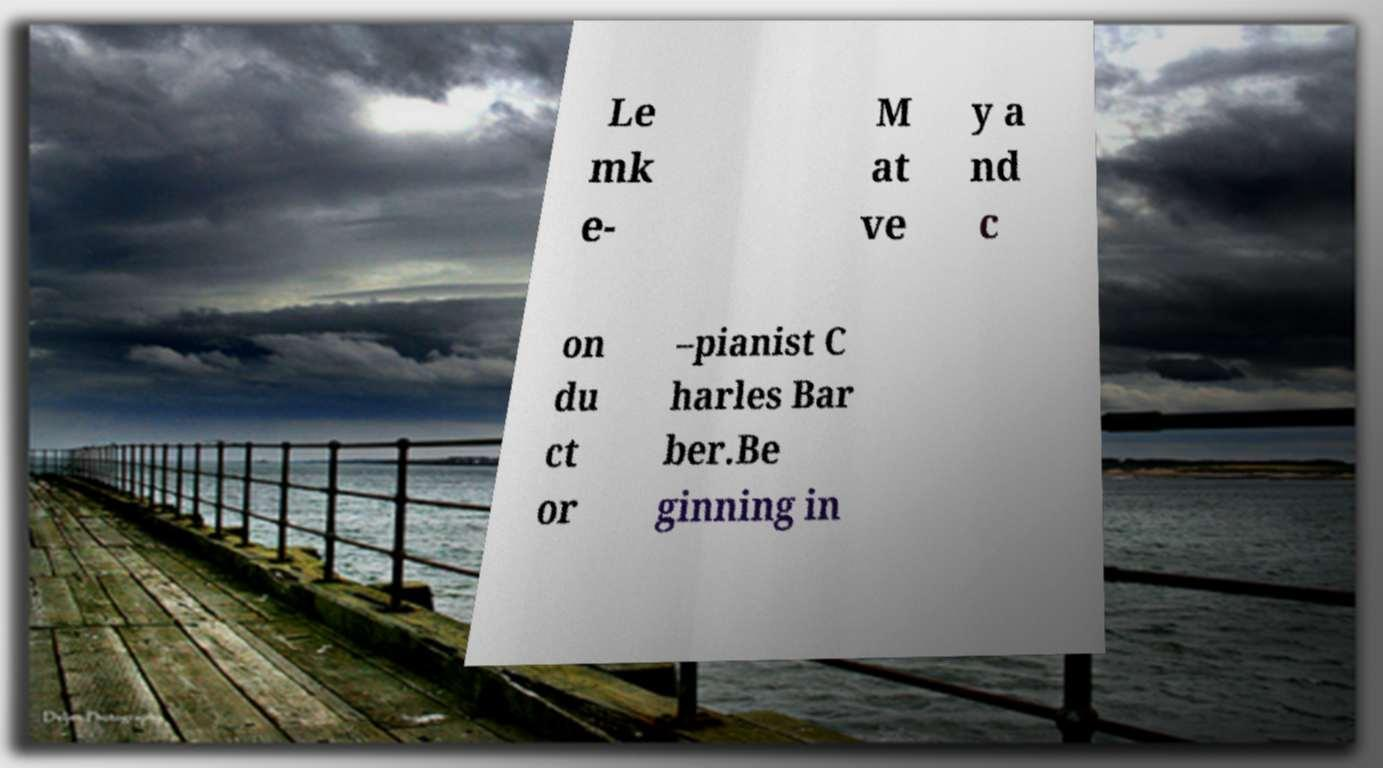Could you extract and type out the text from this image? Le mk e- M at ve y a nd c on du ct or –pianist C harles Bar ber.Be ginning in 